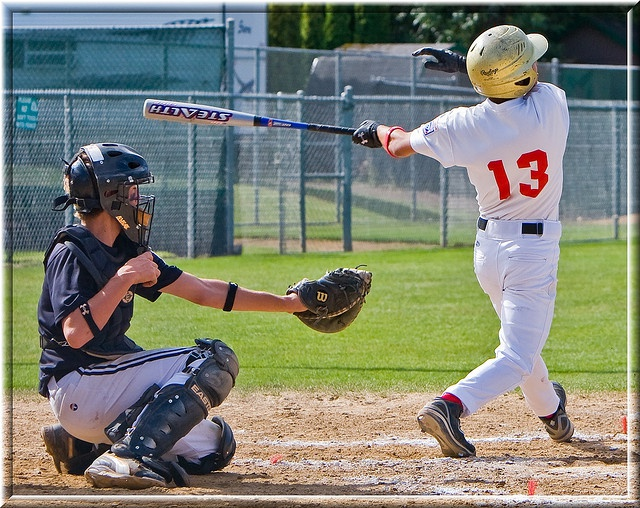Describe the objects in this image and their specific colors. I can see people in white, black, gray, and brown tones, people in white, darkgray, and lightgray tones, baseball glove in white, black, olive, and gray tones, and baseball bat in white, darkgray, black, and gray tones in this image. 